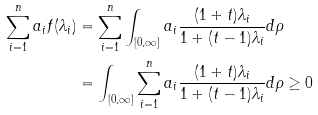<formula> <loc_0><loc_0><loc_500><loc_500>\sum _ { i = 1 } ^ { n } a _ { i } f ( \lambda _ { i } ) & = \sum _ { i = 1 } ^ { n } \int _ { [ 0 , \infty ] } a _ { i } \frac { ( 1 + t ) \lambda _ { i } } { 1 + ( t - 1 ) \lambda _ { i } } d \rho \\ & = \int _ { [ 0 , \infty ] } \sum _ { i = 1 } ^ { n } a _ { i } \frac { ( 1 + t ) \lambda _ { i } } { 1 + ( t - 1 ) \lambda _ { i } } d \rho \geq 0</formula> 